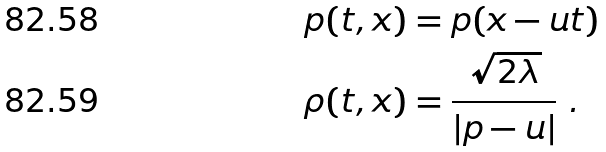Convert formula to latex. <formula><loc_0><loc_0><loc_500><loc_500>p ( t , x ) & = p ( x - u t ) \\ \rho ( t , x ) & = \frac { \sqrt { 2 \lambda } } { \left | p - u \right | } \ .</formula> 